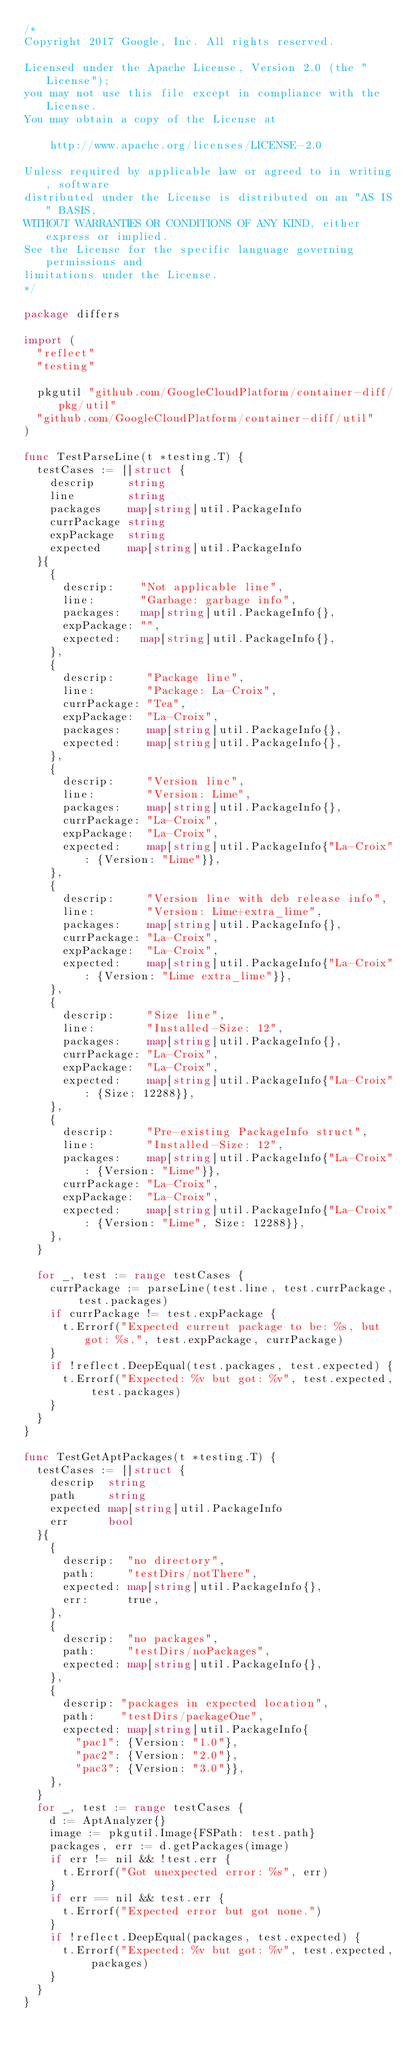<code> <loc_0><loc_0><loc_500><loc_500><_Go_>/*
Copyright 2017 Google, Inc. All rights reserved.

Licensed under the Apache License, Version 2.0 (the "License");
you may not use this file except in compliance with the License.
You may obtain a copy of the License at

    http://www.apache.org/licenses/LICENSE-2.0

Unless required by applicable law or agreed to in writing, software
distributed under the License is distributed on an "AS IS" BASIS,
WITHOUT WARRANTIES OR CONDITIONS OF ANY KIND, either express or implied.
See the License for the specific language governing permissions and
limitations under the License.
*/

package differs

import (
	"reflect"
	"testing"

	pkgutil "github.com/GoogleCloudPlatform/container-diff/pkg/util"
	"github.com/GoogleCloudPlatform/container-diff/util"
)

func TestParseLine(t *testing.T) {
	testCases := []struct {
		descrip     string
		line        string
		packages    map[string]util.PackageInfo
		currPackage string
		expPackage  string
		expected    map[string]util.PackageInfo
	}{
		{
			descrip:    "Not applicable line",
			line:       "Garbage: garbage info",
			packages:   map[string]util.PackageInfo{},
			expPackage: "",
			expected:   map[string]util.PackageInfo{},
		},
		{
			descrip:     "Package line",
			line:        "Package: La-Croix",
			currPackage: "Tea",
			expPackage:  "La-Croix",
			packages:    map[string]util.PackageInfo{},
			expected:    map[string]util.PackageInfo{},
		},
		{
			descrip:     "Version line",
			line:        "Version: Lime",
			packages:    map[string]util.PackageInfo{},
			currPackage: "La-Croix",
			expPackage:  "La-Croix",
			expected:    map[string]util.PackageInfo{"La-Croix": {Version: "Lime"}},
		},
		{
			descrip:     "Version line with deb release info",
			line:        "Version: Lime+extra_lime",
			packages:    map[string]util.PackageInfo{},
			currPackage: "La-Croix",
			expPackage:  "La-Croix",
			expected:    map[string]util.PackageInfo{"La-Croix": {Version: "Lime extra_lime"}},
		},
		{
			descrip:     "Size line",
			line:        "Installed-Size: 12",
			packages:    map[string]util.PackageInfo{},
			currPackage: "La-Croix",
			expPackage:  "La-Croix",
			expected:    map[string]util.PackageInfo{"La-Croix": {Size: 12288}},
		},
		{
			descrip:     "Pre-existing PackageInfo struct",
			line:        "Installed-Size: 12",
			packages:    map[string]util.PackageInfo{"La-Croix": {Version: "Lime"}},
			currPackage: "La-Croix",
			expPackage:  "La-Croix",
			expected:    map[string]util.PackageInfo{"La-Croix": {Version: "Lime", Size: 12288}},
		},
	}

	for _, test := range testCases {
		currPackage := parseLine(test.line, test.currPackage, test.packages)
		if currPackage != test.expPackage {
			t.Errorf("Expected current package to be: %s, but got: %s.", test.expPackage, currPackage)
		}
		if !reflect.DeepEqual(test.packages, test.expected) {
			t.Errorf("Expected: %v but got: %v", test.expected, test.packages)
		}
	}
}

func TestGetAptPackages(t *testing.T) {
	testCases := []struct {
		descrip  string
		path     string
		expected map[string]util.PackageInfo
		err      bool
	}{
		{
			descrip:  "no directory",
			path:     "testDirs/notThere",
			expected: map[string]util.PackageInfo{},
			err:      true,
		},
		{
			descrip:  "no packages",
			path:     "testDirs/noPackages",
			expected: map[string]util.PackageInfo{},
		},
		{
			descrip: "packages in expected location",
			path:    "testDirs/packageOne",
			expected: map[string]util.PackageInfo{
				"pac1": {Version: "1.0"},
				"pac2": {Version: "2.0"},
				"pac3": {Version: "3.0"}},
		},
	}
	for _, test := range testCases {
		d := AptAnalyzer{}
		image := pkgutil.Image{FSPath: test.path}
		packages, err := d.getPackages(image)
		if err != nil && !test.err {
			t.Errorf("Got unexpected error: %s", err)
		}
		if err == nil && test.err {
			t.Errorf("Expected error but got none.")
		}
		if !reflect.DeepEqual(packages, test.expected) {
			t.Errorf("Expected: %v but got: %v", test.expected, packages)
		}
	}
}
</code> 